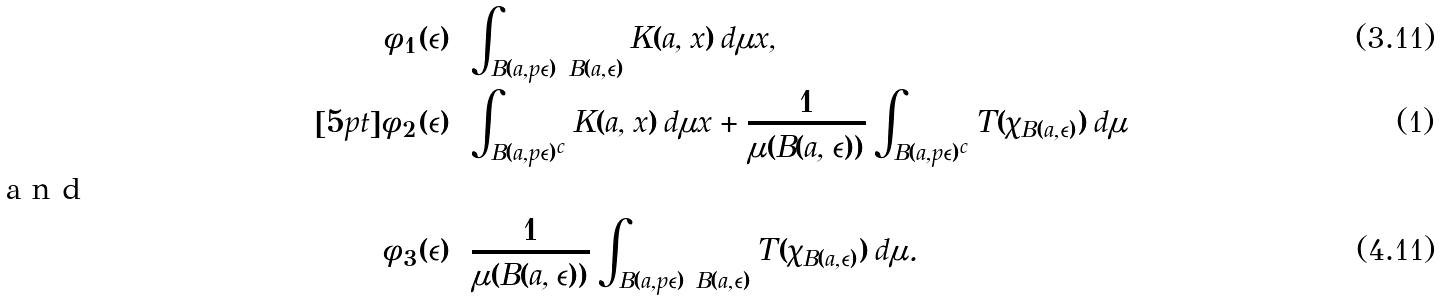Convert formula to latex. <formula><loc_0><loc_0><loc_500><loc_500>\phi _ { 1 } ( \epsilon ) & = \int _ { B ( a , p \epsilon ) \ B ( a , \epsilon ) } K ( a , x ) \, d \mu x , \\ [ 5 p t ] \phi _ { 2 } ( \epsilon ) & = \int _ { B ( a , p \epsilon ) ^ { c } } K ( a , x ) \, d \mu x + \frac { 1 } { \mu ( B ( a , \epsilon ) ) } \int _ { B ( a , p \epsilon ) ^ { c } } T ( \chi _ { B ( a , \epsilon ) } ) \, d \mu \intertext { a n d } \phi _ { 3 } ( \epsilon ) & = \frac { 1 } { \mu ( B ( a , \epsilon ) ) } \int _ { B ( a , p \epsilon ) \ B ( a , \epsilon ) } T ( \chi _ { B ( a , \epsilon ) } ) \, d \mu .</formula> 